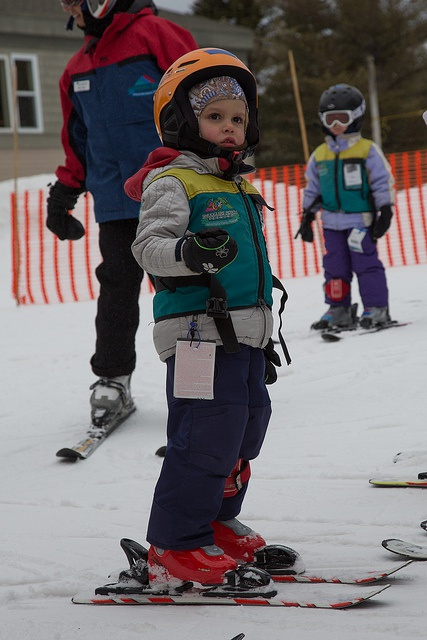Describe the objects in this image and their specific colors. I can see people in black, gray, darkgray, and maroon tones, people in black, maroon, gray, and navy tones, people in black, navy, and gray tones, skis in black, darkgray, gray, and maroon tones, and skis in black, darkgray, gray, and lightgray tones in this image. 